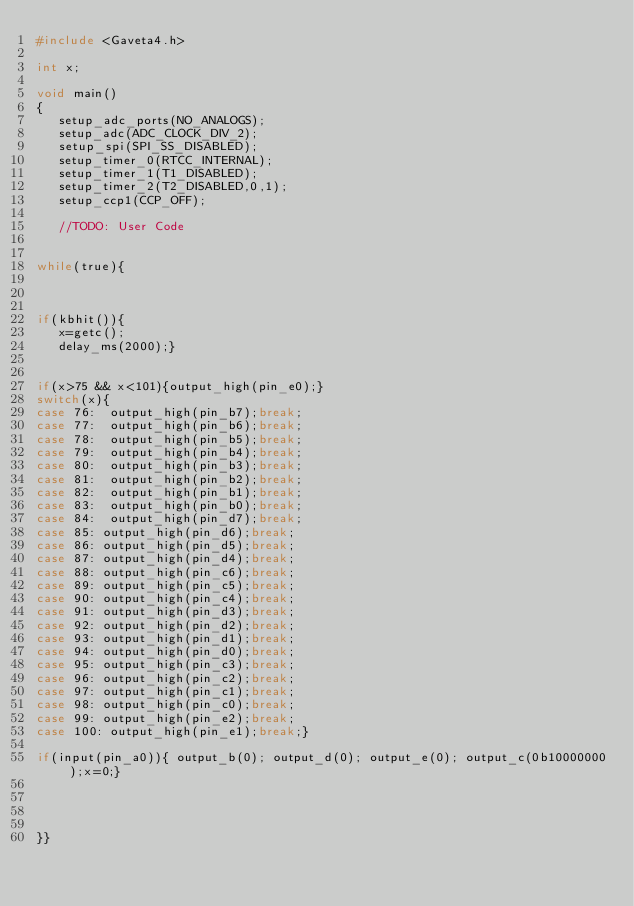Convert code to text. <code><loc_0><loc_0><loc_500><loc_500><_C_>#include <Gaveta4.h>

int x;

void main()
{
   setup_adc_ports(NO_ANALOGS);
   setup_adc(ADC_CLOCK_DIV_2);
   setup_spi(SPI_SS_DISABLED);
   setup_timer_0(RTCC_INTERNAL);
   setup_timer_1(T1_DISABLED);
   setup_timer_2(T2_DISABLED,0,1);
   setup_ccp1(CCP_OFF);

   //TODO: User Code


while(true){



if(kbhit()){
   x=getc();
   delay_ms(2000);}


if(x>75 && x<101){output_high(pin_e0);}
switch(x){
case 76:  output_high(pin_b7);break;
case 77:  output_high(pin_b6);break;
case 78:  output_high(pin_b5);break;
case 79:  output_high(pin_b4);break;
case 80:  output_high(pin_b3);break;
case 81:  output_high(pin_b2);break;
case 82:  output_high(pin_b1);break;
case 83:  output_high(pin_b0);break;
case 84:  output_high(pin_d7);break;
case 85: output_high(pin_d6);break;
case 86: output_high(pin_d5);break;
case 87: output_high(pin_d4);break;
case 88: output_high(pin_c6);break;
case 89: output_high(pin_c5);break;
case 90: output_high(pin_c4);break;
case 91: output_high(pin_d3);break;
case 92: output_high(pin_d2);break;
case 93: output_high(pin_d1);break;
case 94: output_high(pin_d0);break;
case 95: output_high(pin_c3);break;
case 96: output_high(pin_c2);break;
case 97: output_high(pin_c1);break;
case 98: output_high(pin_c0);break;
case 99: output_high(pin_e2);break;
case 100: output_high(pin_e1);break;}

if(input(pin_a0)){ output_b(0); output_d(0); output_e(0); output_c(0b10000000);x=0;}




}}



</code> 